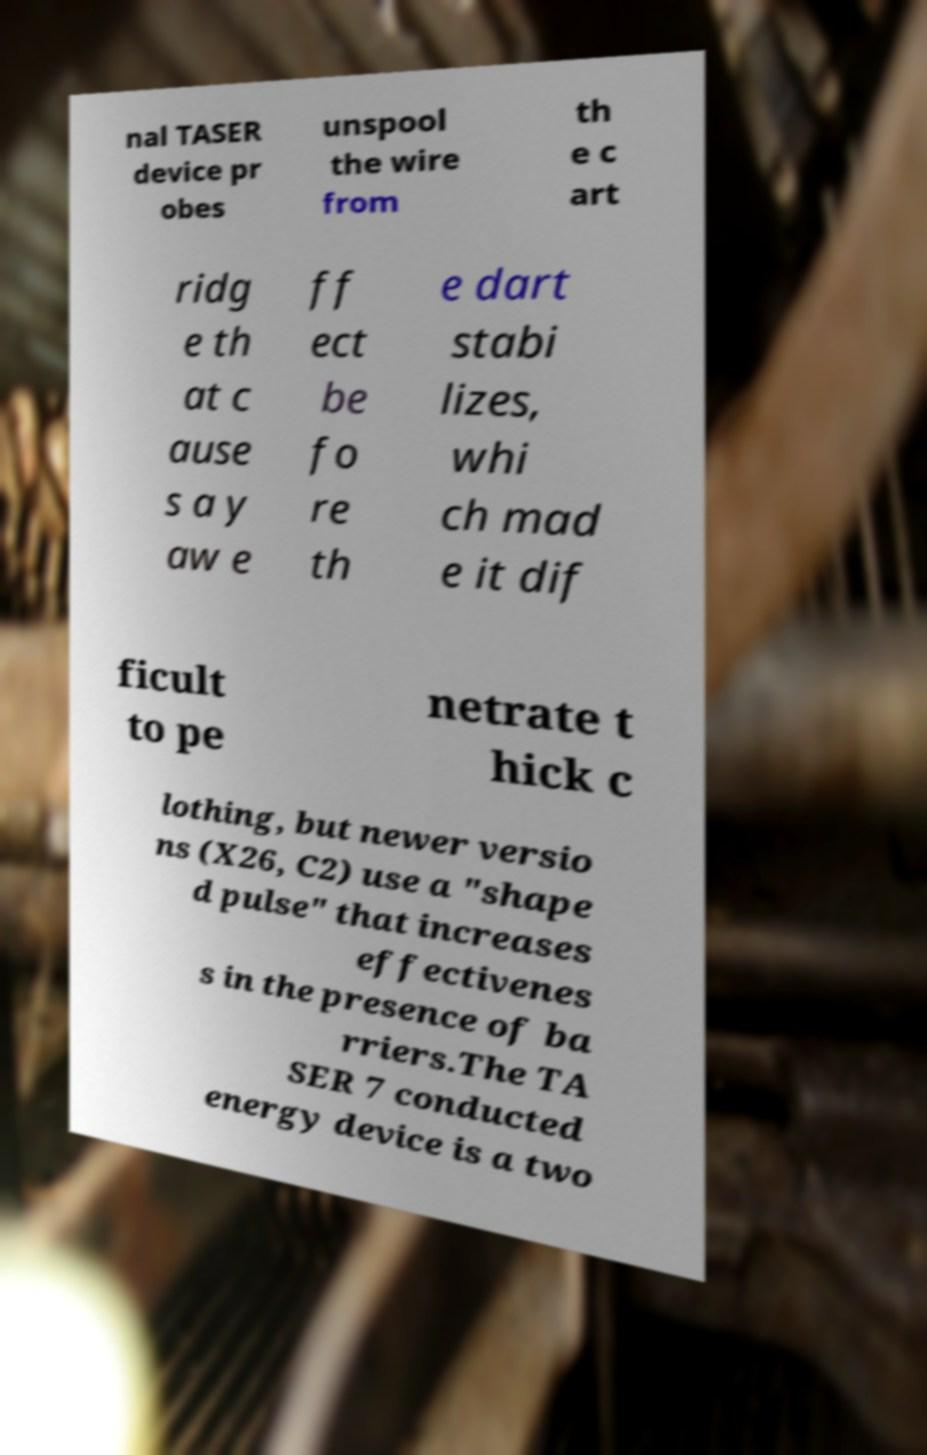There's text embedded in this image that I need extracted. Can you transcribe it verbatim? nal TASER device pr obes unspool the wire from th e c art ridg e th at c ause s a y aw e ff ect be fo re th e dart stabi lizes, whi ch mad e it dif ficult to pe netrate t hick c lothing, but newer versio ns (X26, C2) use a "shape d pulse" that increases effectivenes s in the presence of ba rriers.The TA SER 7 conducted energy device is a two 